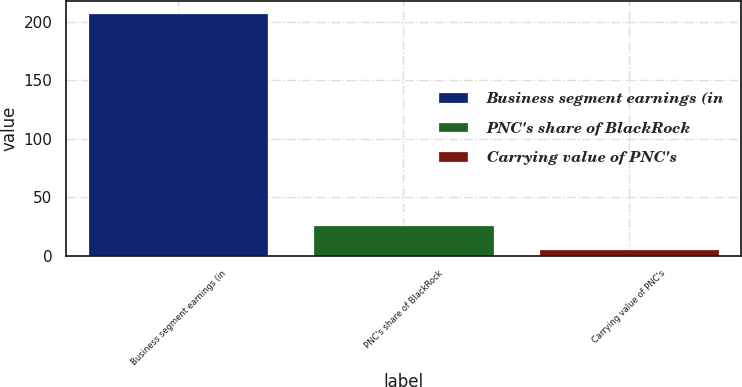<chart> <loc_0><loc_0><loc_500><loc_500><bar_chart><fcel>Business segment earnings (in<fcel>PNC's share of BlackRock<fcel>Carrying value of PNC's<nl><fcel>207<fcel>25.92<fcel>5.8<nl></chart> 